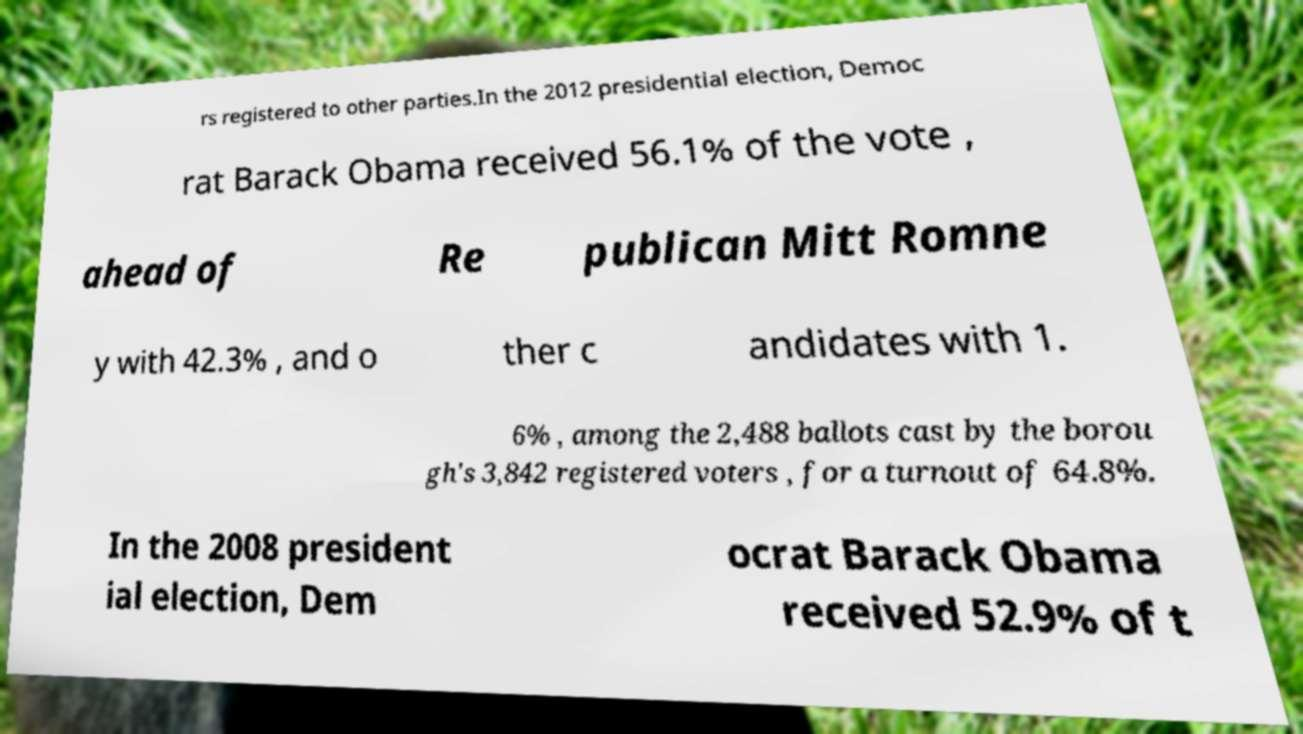What messages or text are displayed in this image? I need them in a readable, typed format. rs registered to other parties.In the 2012 presidential election, Democ rat Barack Obama received 56.1% of the vote , ahead of Re publican Mitt Romne y with 42.3% , and o ther c andidates with 1. 6% , among the 2,488 ballots cast by the borou gh's 3,842 registered voters , for a turnout of 64.8%. In the 2008 president ial election, Dem ocrat Barack Obama received 52.9% of t 